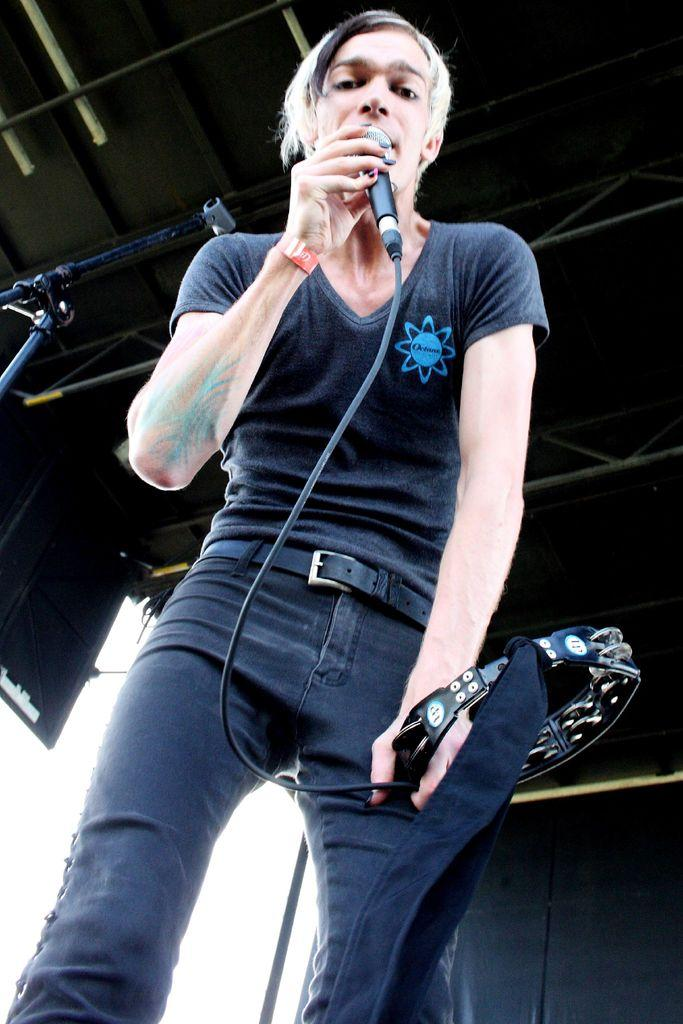What is the person in the image holding? The person is holding a mic and a musical instrument. What might the person be doing in the image? The person might be performing or playing music, given that they are holding a mic and a musical instrument. What can be seen in the background of the image? There is a wall in the background of the image. What else is visible in the image besides the person and the wall? There are rods visible in the image. What type of bat can be seen flying in the image? There is no bat present in the image; it features a person holding a mic and a musical instrument. 